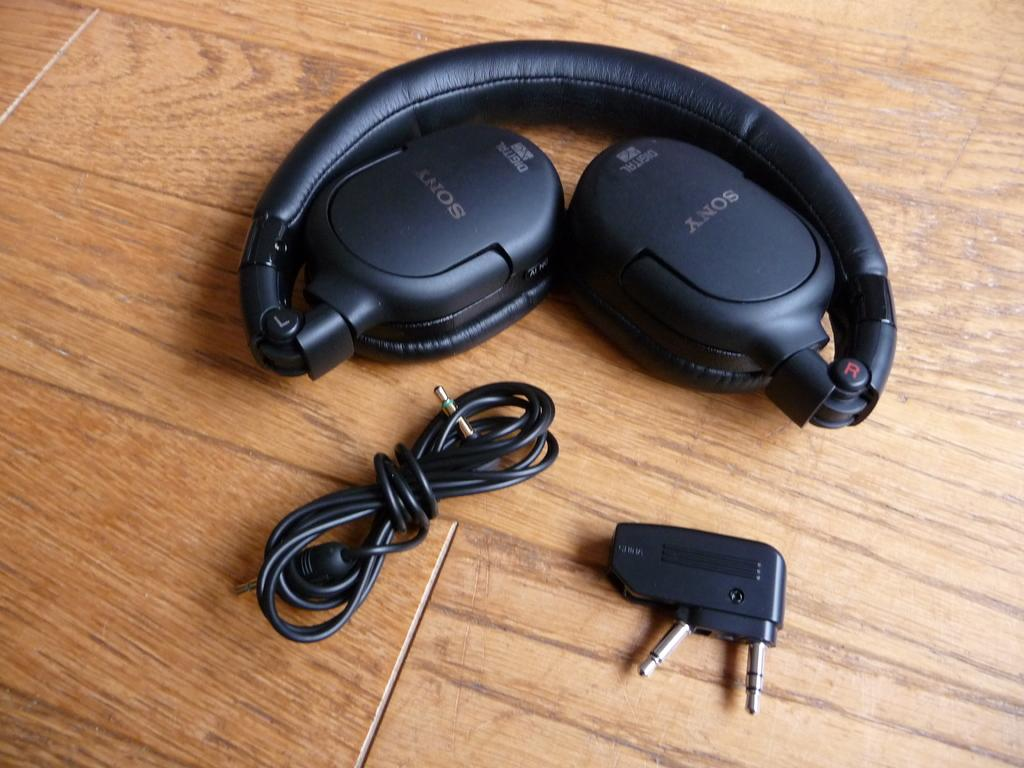What type of device is featured in the image? There is a headset in the image. What is connected to the headset in the image? There is a cable in the image. What other accessory is present in the image? There is an adapter in the image. On what surface are the objects placed in the image? The objects are placed on a brown table. What type of book is the person reading in the image? There is no person or book present in the image; it only features a headset, cable, and adapter on a brown table. What type of cannon is visible in the image? There is no cannon present in the image. What is the digestive process of the person in the image? There is no person present in the image, so it is not possible to determine their digestive process. 